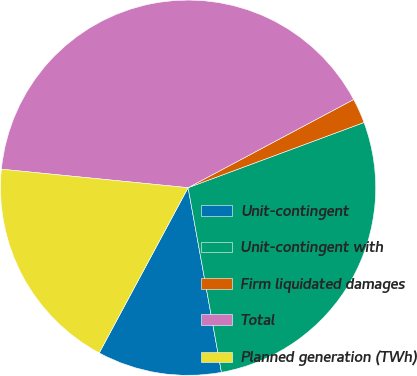Convert chart. <chart><loc_0><loc_0><loc_500><loc_500><pie_chart><fcel>Unit-contingent<fcel>Unit-contingent with<fcel>Firm liquidated damages<fcel>Total<fcel>Planned generation (TWh)<nl><fcel>10.7%<fcel>27.81%<fcel>2.14%<fcel>40.64%<fcel>18.72%<nl></chart> 